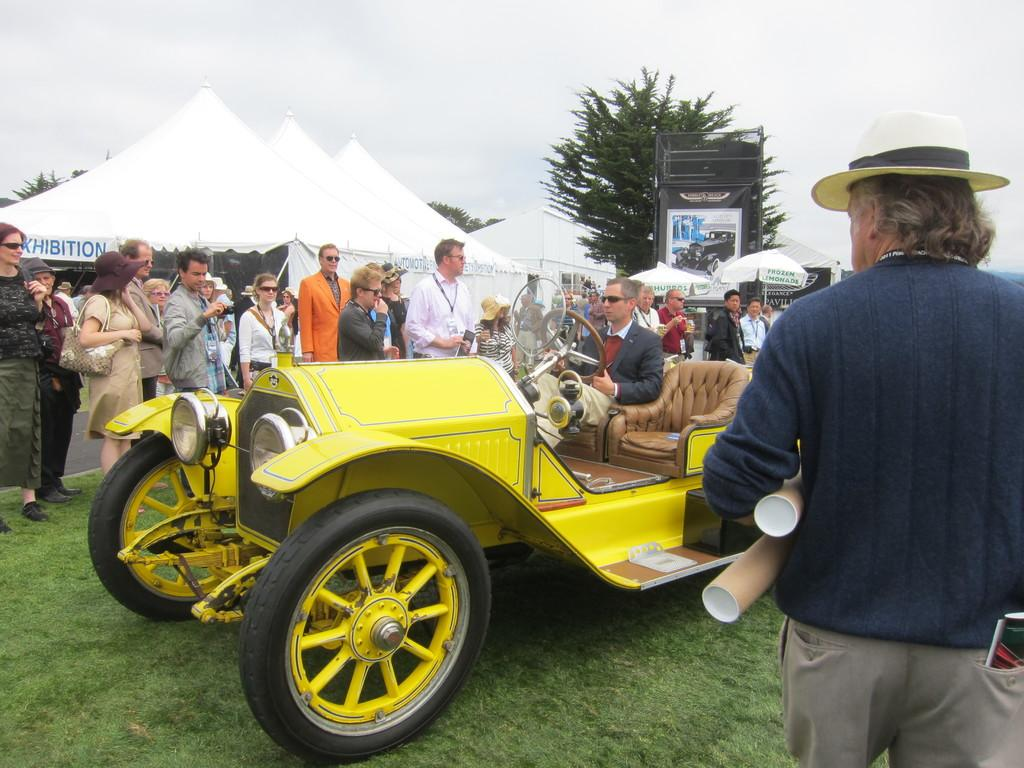What is the main subject of the image? The main subject of the image is a car. Are there any people in the image? Yes, there are persons in the image. What else can be seen in the image besides the car and people? There are tents, trees, umbrellas, an advertisement, and the sky visible in the image. What is the condition of the sky in the image? The sky is visible in the image, and clouds are present. Can you tell me how many bats are hanging from the car in the image? There are no bats present in the image; it features a car, people, tents, trees, umbrellas, an advertisement, and the sky with clouds. What type of carriage is being used by the persons in the image? There is no carriage present in the image; it features a car, people, tents, trees, umbrellas, an advertisement, and the sky with clouds. 